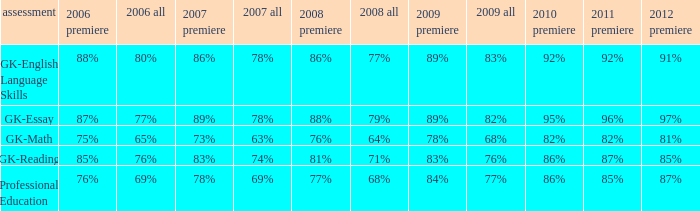What is the percentage for 2008 First time when in 2006 it was 85%? 81%. 